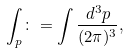Convert formula to latex. <formula><loc_0><loc_0><loc_500><loc_500>\int _ { p } \colon = \int \frac { d ^ { 3 } p } { ( 2 \pi ) ^ { 3 } } ,</formula> 